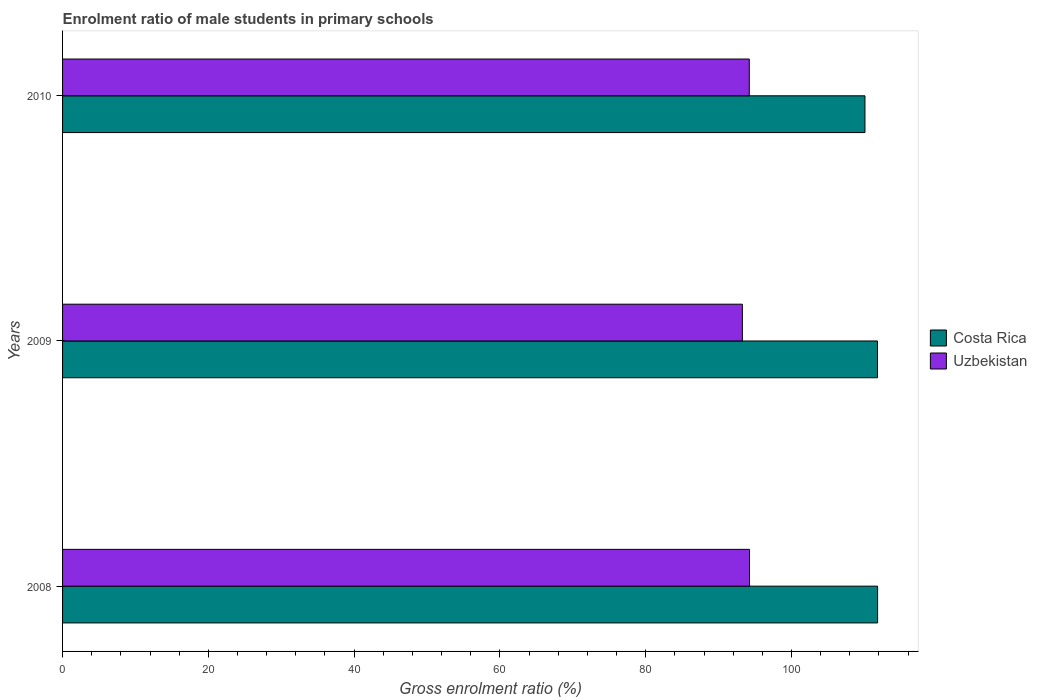How many different coloured bars are there?
Ensure brevity in your answer.  2. How many groups of bars are there?
Your answer should be compact. 3. Are the number of bars per tick equal to the number of legend labels?
Your answer should be compact. Yes. Are the number of bars on each tick of the Y-axis equal?
Your response must be concise. Yes. What is the label of the 3rd group of bars from the top?
Give a very brief answer. 2008. In how many cases, is the number of bars for a given year not equal to the number of legend labels?
Give a very brief answer. 0. What is the enrolment ratio of male students in primary schools in Costa Rica in 2010?
Make the answer very short. 110.08. Across all years, what is the maximum enrolment ratio of male students in primary schools in Costa Rica?
Provide a succinct answer. 111.82. Across all years, what is the minimum enrolment ratio of male students in primary schools in Uzbekistan?
Keep it short and to the point. 93.27. In which year was the enrolment ratio of male students in primary schools in Costa Rica maximum?
Your answer should be very brief. 2008. What is the total enrolment ratio of male students in primary schools in Uzbekistan in the graph?
Your answer should be compact. 281.72. What is the difference between the enrolment ratio of male students in primary schools in Costa Rica in 2009 and that in 2010?
Keep it short and to the point. 1.72. What is the difference between the enrolment ratio of male students in primary schools in Uzbekistan in 2010 and the enrolment ratio of male students in primary schools in Costa Rica in 2009?
Make the answer very short. -17.59. What is the average enrolment ratio of male students in primary schools in Costa Rica per year?
Give a very brief answer. 111.23. In the year 2009, what is the difference between the enrolment ratio of male students in primary schools in Uzbekistan and enrolment ratio of male students in primary schools in Costa Rica?
Offer a very short reply. -18.54. What is the ratio of the enrolment ratio of male students in primary schools in Uzbekistan in 2008 to that in 2010?
Your answer should be very brief. 1. Is the enrolment ratio of male students in primary schools in Costa Rica in 2009 less than that in 2010?
Provide a short and direct response. No. What is the difference between the highest and the second highest enrolment ratio of male students in primary schools in Costa Rica?
Provide a short and direct response. 0.02. What is the difference between the highest and the lowest enrolment ratio of male students in primary schools in Uzbekistan?
Keep it short and to the point. 0.98. In how many years, is the enrolment ratio of male students in primary schools in Uzbekistan greater than the average enrolment ratio of male students in primary schools in Uzbekistan taken over all years?
Your answer should be compact. 2. Is the sum of the enrolment ratio of male students in primary schools in Uzbekistan in 2009 and 2010 greater than the maximum enrolment ratio of male students in primary schools in Costa Rica across all years?
Ensure brevity in your answer.  Yes. What does the 1st bar from the top in 2008 represents?
Offer a terse response. Uzbekistan. What does the 2nd bar from the bottom in 2008 represents?
Give a very brief answer. Uzbekistan. How many years are there in the graph?
Your answer should be very brief. 3. What is the difference between two consecutive major ticks on the X-axis?
Make the answer very short. 20. Does the graph contain grids?
Provide a short and direct response. No. Where does the legend appear in the graph?
Offer a very short reply. Center right. How many legend labels are there?
Offer a terse response. 2. What is the title of the graph?
Provide a succinct answer. Enrolment ratio of male students in primary schools. Does "West Bank and Gaza" appear as one of the legend labels in the graph?
Ensure brevity in your answer.  No. What is the label or title of the X-axis?
Your answer should be very brief. Gross enrolment ratio (%). What is the label or title of the Y-axis?
Offer a very short reply. Years. What is the Gross enrolment ratio (%) of Costa Rica in 2008?
Give a very brief answer. 111.82. What is the Gross enrolment ratio (%) of Uzbekistan in 2008?
Give a very brief answer. 94.25. What is the Gross enrolment ratio (%) of Costa Rica in 2009?
Ensure brevity in your answer.  111.8. What is the Gross enrolment ratio (%) in Uzbekistan in 2009?
Offer a very short reply. 93.27. What is the Gross enrolment ratio (%) in Costa Rica in 2010?
Ensure brevity in your answer.  110.08. What is the Gross enrolment ratio (%) of Uzbekistan in 2010?
Your answer should be compact. 94.21. Across all years, what is the maximum Gross enrolment ratio (%) of Costa Rica?
Keep it short and to the point. 111.82. Across all years, what is the maximum Gross enrolment ratio (%) of Uzbekistan?
Ensure brevity in your answer.  94.25. Across all years, what is the minimum Gross enrolment ratio (%) of Costa Rica?
Keep it short and to the point. 110.08. Across all years, what is the minimum Gross enrolment ratio (%) of Uzbekistan?
Keep it short and to the point. 93.27. What is the total Gross enrolment ratio (%) of Costa Rica in the graph?
Keep it short and to the point. 333.7. What is the total Gross enrolment ratio (%) of Uzbekistan in the graph?
Ensure brevity in your answer.  281.72. What is the difference between the Gross enrolment ratio (%) in Costa Rica in 2008 and that in 2009?
Keep it short and to the point. 0.02. What is the difference between the Gross enrolment ratio (%) in Uzbekistan in 2008 and that in 2009?
Your answer should be compact. 0.98. What is the difference between the Gross enrolment ratio (%) of Costa Rica in 2008 and that in 2010?
Your answer should be very brief. 1.74. What is the difference between the Gross enrolment ratio (%) of Uzbekistan in 2008 and that in 2010?
Make the answer very short. 0.03. What is the difference between the Gross enrolment ratio (%) of Costa Rica in 2009 and that in 2010?
Offer a very short reply. 1.72. What is the difference between the Gross enrolment ratio (%) in Uzbekistan in 2009 and that in 2010?
Your answer should be very brief. -0.95. What is the difference between the Gross enrolment ratio (%) of Costa Rica in 2008 and the Gross enrolment ratio (%) of Uzbekistan in 2009?
Ensure brevity in your answer.  18.55. What is the difference between the Gross enrolment ratio (%) of Costa Rica in 2008 and the Gross enrolment ratio (%) of Uzbekistan in 2010?
Make the answer very short. 17.61. What is the difference between the Gross enrolment ratio (%) in Costa Rica in 2009 and the Gross enrolment ratio (%) in Uzbekistan in 2010?
Provide a short and direct response. 17.59. What is the average Gross enrolment ratio (%) in Costa Rica per year?
Offer a terse response. 111.23. What is the average Gross enrolment ratio (%) in Uzbekistan per year?
Provide a short and direct response. 93.91. In the year 2008, what is the difference between the Gross enrolment ratio (%) in Costa Rica and Gross enrolment ratio (%) in Uzbekistan?
Offer a terse response. 17.57. In the year 2009, what is the difference between the Gross enrolment ratio (%) in Costa Rica and Gross enrolment ratio (%) in Uzbekistan?
Give a very brief answer. 18.54. In the year 2010, what is the difference between the Gross enrolment ratio (%) of Costa Rica and Gross enrolment ratio (%) of Uzbekistan?
Your answer should be compact. 15.87. What is the ratio of the Gross enrolment ratio (%) of Uzbekistan in 2008 to that in 2009?
Keep it short and to the point. 1.01. What is the ratio of the Gross enrolment ratio (%) in Costa Rica in 2008 to that in 2010?
Your response must be concise. 1.02. What is the ratio of the Gross enrolment ratio (%) of Uzbekistan in 2008 to that in 2010?
Provide a short and direct response. 1. What is the ratio of the Gross enrolment ratio (%) of Costa Rica in 2009 to that in 2010?
Offer a very short reply. 1.02. What is the ratio of the Gross enrolment ratio (%) in Uzbekistan in 2009 to that in 2010?
Provide a short and direct response. 0.99. What is the difference between the highest and the second highest Gross enrolment ratio (%) of Costa Rica?
Your answer should be very brief. 0.02. What is the difference between the highest and the second highest Gross enrolment ratio (%) in Uzbekistan?
Provide a short and direct response. 0.03. What is the difference between the highest and the lowest Gross enrolment ratio (%) of Costa Rica?
Your response must be concise. 1.74. What is the difference between the highest and the lowest Gross enrolment ratio (%) of Uzbekistan?
Your answer should be very brief. 0.98. 